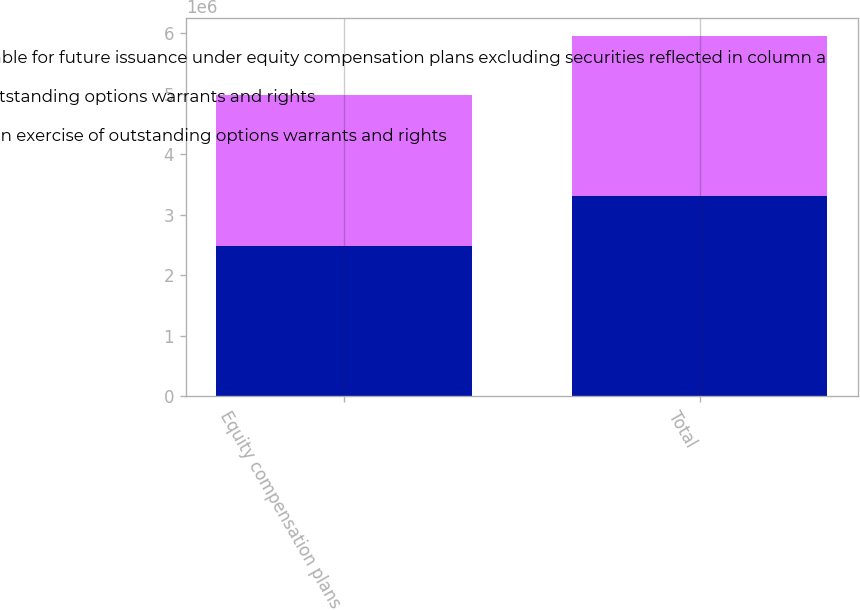Convert chart. <chart><loc_0><loc_0><loc_500><loc_500><stacked_bar_chart><ecel><fcel>Equity compensation plans<fcel>Total<nl><fcel>Number of securities remaining available for future issuance under equity compensation plans excluding securities reflected in column a<fcel>2.48954e+06<fcel>3.30412e+06<nl><fcel>Weightedaverage exercise price of outstanding options warrants and rights<fcel>34.23<fcel>34.23<nl><fcel>Number of securities to be issued upon exercise of outstanding options warrants and rights<fcel>2.48954e+06<fcel>2.65364e+06<nl></chart> 